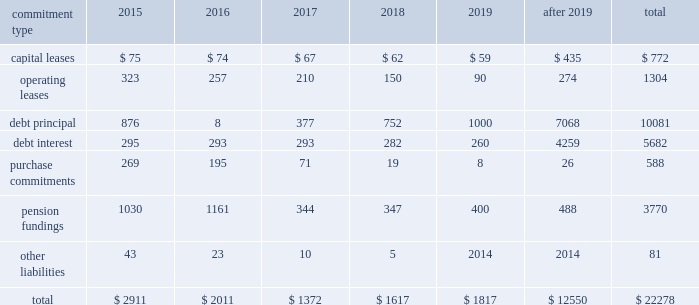United parcel service , inc .
And subsidiaries management's discussion and analysis of financial condition and results of operations issuances of debt in 2014 and 2013 consisted primarily of longer-maturity commercial paper .
Issuances of debt in 2012 consisted primarily of senior fixed rate note offerings totaling $ 1.75 billion .
Repayments of debt in 2014 and 2013 consisted primarily of the maturity of our $ 1.0 and $ 1.75 billion senior fixed rate notes that matured in april 2014 and january 2013 , respectively .
The remaining repayments of debt during the 2012 through 2014 time period included paydowns of commercial paper and scheduled principal payments on our capitalized lease obligations .
We consider the overall fixed and floating interest rate mix of our portfolio and the related overall cost of borrowing when planning for future issuances and non-scheduled repayments of debt .
We had $ 772 million of commercial paper outstanding at december 31 , 2014 , and no commercial paper outstanding at december 31 , 2013 and 2012 .
The amount of commercial paper outstanding fluctuates throughout each year based on daily liquidity needs .
The average commercial paper balance was $ 1.356 billion and the average interest rate paid was 0.10% ( 0.10 % ) in 2014 ( $ 1.013 billion and 0.07% ( 0.07 % ) in 2013 , and $ 962 million and 0.07% ( 0.07 % ) in 2012 , respectively ) .
The variation in cash received from common stock issuances to employees was primarily due to level of stock option exercises in the 2012 through 2014 period .
The cash outflows in other financing activities were impacted by several factors .
Cash inflows ( outflows ) from the premium payments and settlements of capped call options for the purchase of ups class b shares were $ ( 47 ) , $ ( 93 ) and $ 206 million for 2014 , 2013 and 2012 , respectively .
Cash outflows related to the repurchase of shares to satisfy tax withholding obligations on vested employee stock awards were $ 224 , $ 253 and $ 234 million for 2014 , 2013 and 2012 , respectively .
In 2013 , we paid $ 70 million to purchase the noncontrolling interest in a joint venture that operates in the middle east , turkey and portions of the central asia region .
In 2012 , we settled several interest rate derivatives that were designated as hedges of the senior fixed-rate debt offerings that year , which resulted in a cash outflow of $ 70 million .
Sources of credit see note 7 to the audited consolidated financial statements for a discussion of our available credit and debt covenants .
Guarantees and other off-balance sheet arrangements we do not have guarantees or other off-balance sheet financing arrangements , including variable interest entities , which we believe could have a material impact on financial condition or liquidity .
Contractual commitments we have contractual obligations and commitments in the form of capital leases , operating leases , debt obligations , purchase commitments , and certain other liabilities .
We intend to satisfy these obligations through the use of cash flow from operations .
The table summarizes the expected cash outflow to satisfy our contractual obligations and commitments as of december 31 , 2014 ( in millions ) : .

What percent of total expected cash outflow to satisfy contractual obligations and commitments as of december 31 , 2014 , is pension fundings? 
Computations: (3770 / 22278)
Answer: 0.16923. United parcel service , inc .
And subsidiaries management's discussion and analysis of financial condition and results of operations issuances of debt in 2014 and 2013 consisted primarily of longer-maturity commercial paper .
Issuances of debt in 2012 consisted primarily of senior fixed rate note offerings totaling $ 1.75 billion .
Repayments of debt in 2014 and 2013 consisted primarily of the maturity of our $ 1.0 and $ 1.75 billion senior fixed rate notes that matured in april 2014 and january 2013 , respectively .
The remaining repayments of debt during the 2012 through 2014 time period included paydowns of commercial paper and scheduled principal payments on our capitalized lease obligations .
We consider the overall fixed and floating interest rate mix of our portfolio and the related overall cost of borrowing when planning for future issuances and non-scheduled repayments of debt .
We had $ 772 million of commercial paper outstanding at december 31 , 2014 , and no commercial paper outstanding at december 31 , 2013 and 2012 .
The amount of commercial paper outstanding fluctuates throughout each year based on daily liquidity needs .
The average commercial paper balance was $ 1.356 billion and the average interest rate paid was 0.10% ( 0.10 % ) in 2014 ( $ 1.013 billion and 0.07% ( 0.07 % ) in 2013 , and $ 962 million and 0.07% ( 0.07 % ) in 2012 , respectively ) .
The variation in cash received from common stock issuances to employees was primarily due to level of stock option exercises in the 2012 through 2014 period .
The cash outflows in other financing activities were impacted by several factors .
Cash inflows ( outflows ) from the premium payments and settlements of capped call options for the purchase of ups class b shares were $ ( 47 ) , $ ( 93 ) and $ 206 million for 2014 , 2013 and 2012 , respectively .
Cash outflows related to the repurchase of shares to satisfy tax withholding obligations on vested employee stock awards were $ 224 , $ 253 and $ 234 million for 2014 , 2013 and 2012 , respectively .
In 2013 , we paid $ 70 million to purchase the noncontrolling interest in a joint venture that operates in the middle east , turkey and portions of the central asia region .
In 2012 , we settled several interest rate derivatives that were designated as hedges of the senior fixed-rate debt offerings that year , which resulted in a cash outflow of $ 70 million .
Sources of credit see note 7 to the audited consolidated financial statements for a discussion of our available credit and debt covenants .
Guarantees and other off-balance sheet arrangements we do not have guarantees or other off-balance sheet financing arrangements , including variable interest entities , which we believe could have a material impact on financial condition or liquidity .
Contractual commitments we have contractual obligations and commitments in the form of capital leases , operating leases , debt obligations , purchase commitments , and certain other liabilities .
We intend to satisfy these obligations through the use of cash flow from operations .
The table summarizes the expected cash outflow to satisfy our contractual obligations and commitments as of december 31 , 2014 ( in millions ) : .

What portion of the total contractual obligations is due in 2015? 
Computations: (2911 / 22278)
Answer: 0.13067. 